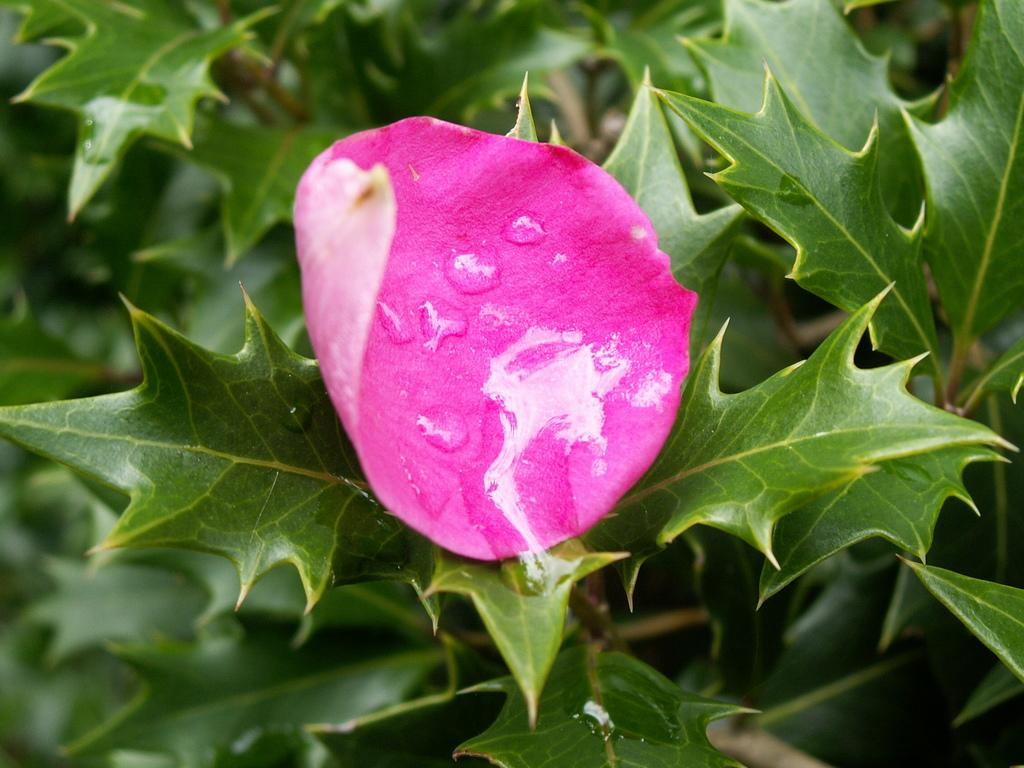What is present on the plant in the image? There is a rose petal on the plant. What can be seen on the rose petal? There are dew drops on the rose petal. What type of guitar is leaning against the mailbox in the image? There is no guitar or mailbox present in the image; it only features a rose petal with dew drops. 